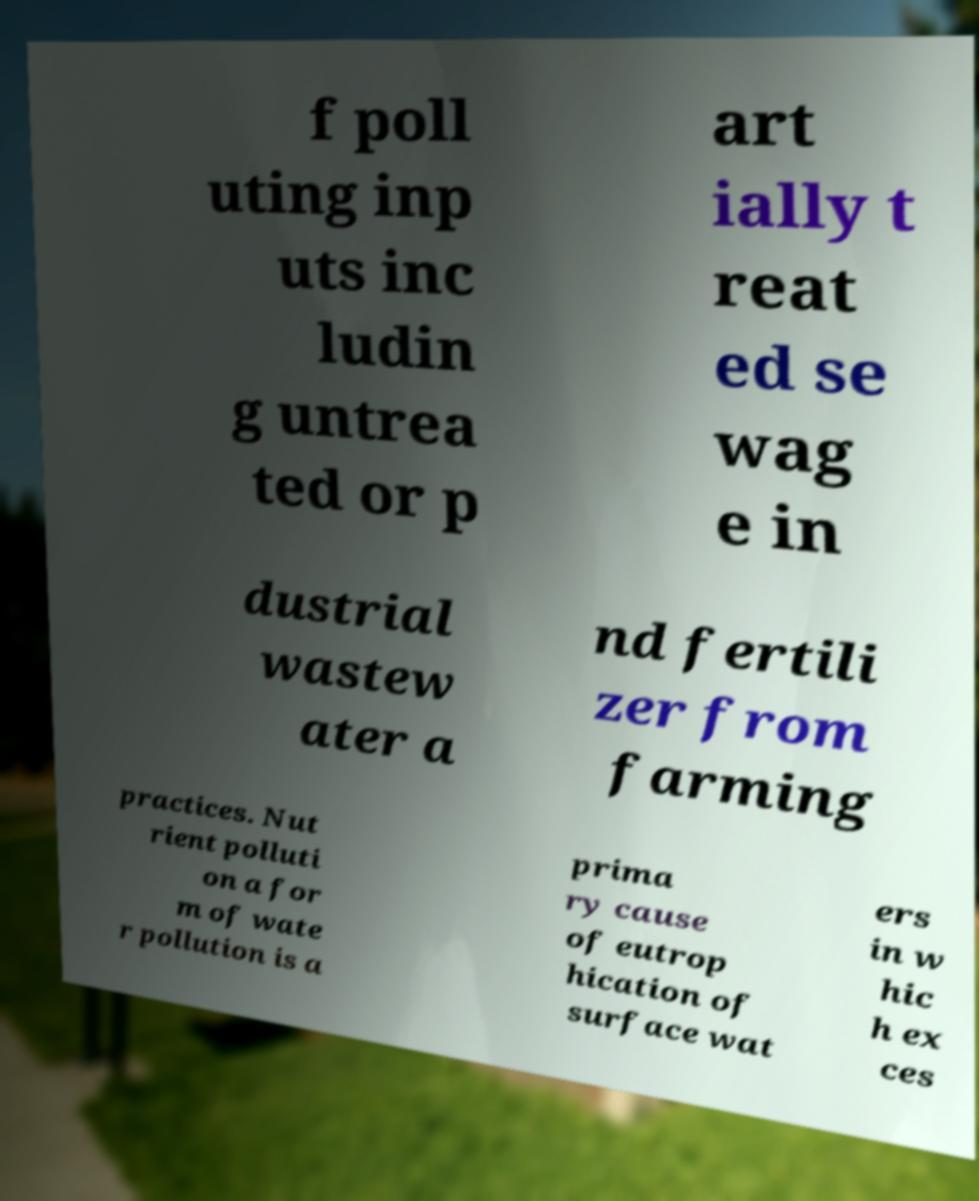There's text embedded in this image that I need extracted. Can you transcribe it verbatim? f poll uting inp uts inc ludin g untrea ted or p art ially t reat ed se wag e in dustrial wastew ater a nd fertili zer from farming practices. Nut rient polluti on a for m of wate r pollution is a prima ry cause of eutrop hication of surface wat ers in w hic h ex ces 